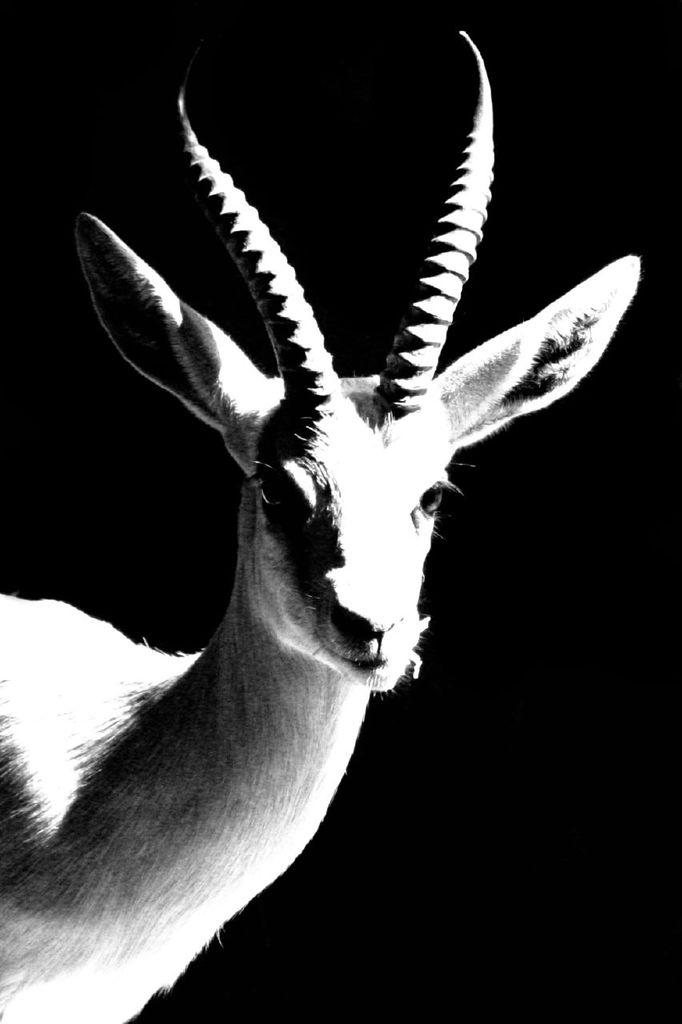What type of living creature is present in the image? There is an animal in the image. What color is the background of the image? The background of the image is black. How much money is visible in the image? There is no money present in the image. What type of cars can be seen in the image? There are no cars present in the image. 